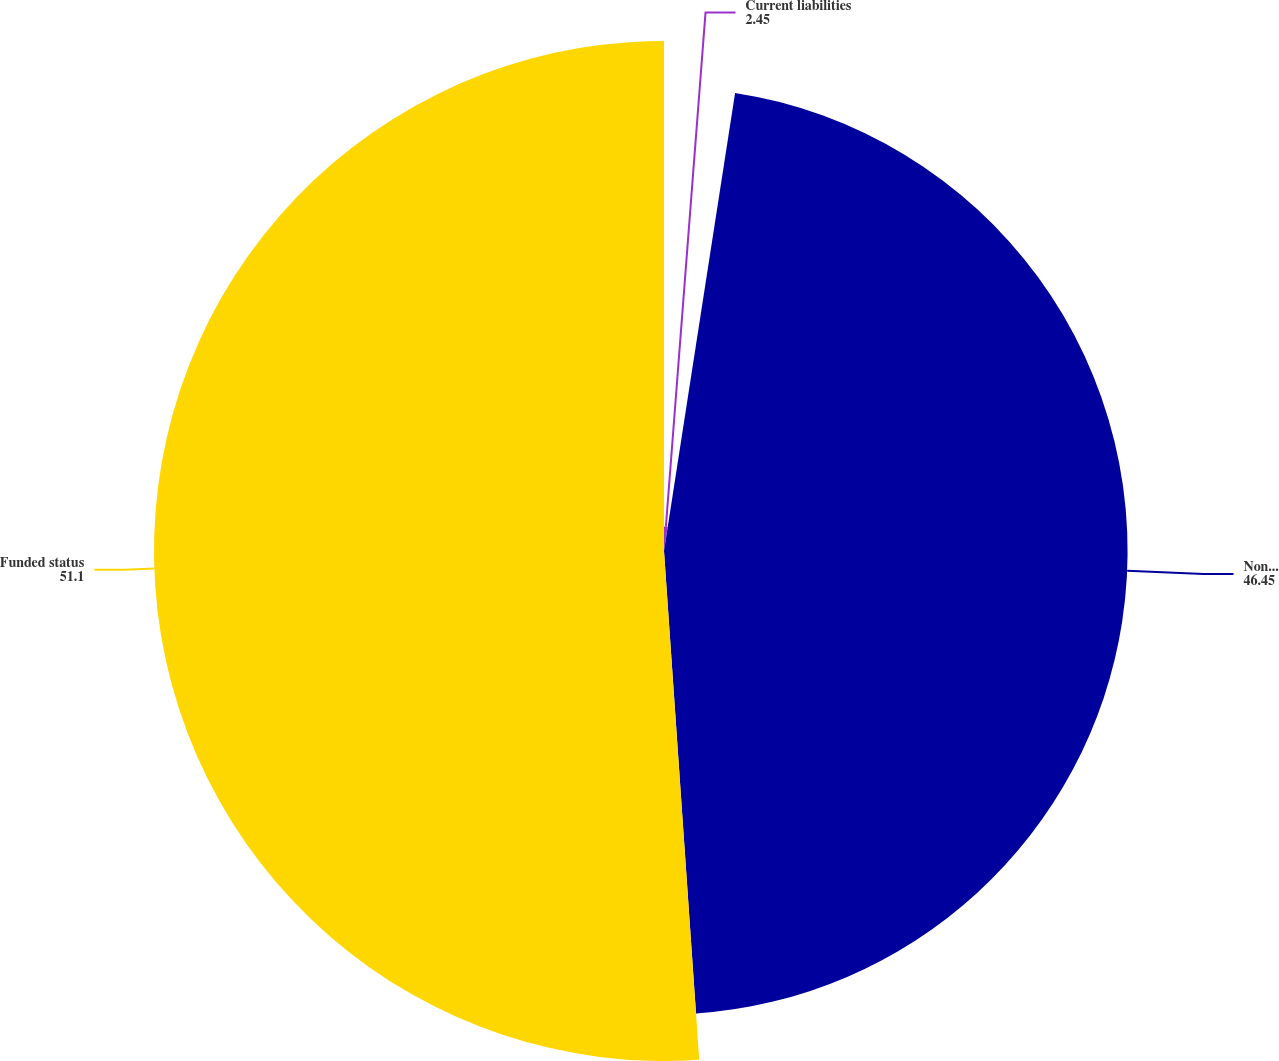<chart> <loc_0><loc_0><loc_500><loc_500><pie_chart><fcel>Current liabilities<fcel>Noncurrent liabilities<fcel>Funded status<nl><fcel>2.45%<fcel>46.45%<fcel>51.1%<nl></chart> 